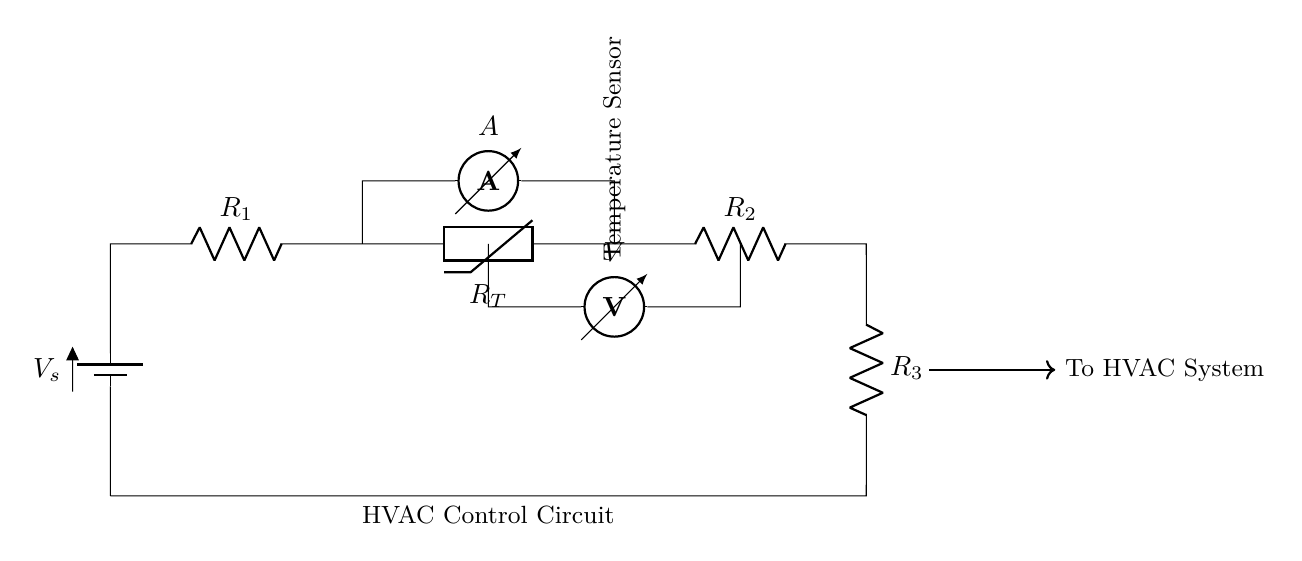What is the power source in this circuit? The power source is indicated by the battery symbol labeled V_s at the left side of the circuit, which provides the necessary voltage for the circuit to operate.
Answer: Battery What components are in series with the thermistor? The thermistor is positioned in a sequence with resistors R_1 and R_2, with R_1 preceding it and R_2 following it, hence they are in series with the thermistor.
Answer: R1, R2 What is the function of the ammeter in the circuit? The ammeter is used to measure the current flowing through the circuit, and it is placed in series with the thermistor to monitor the current specifically through this part of the circuit.
Answer: Measure current How does the temperature affect the circuit's output voltage? The thermistor's resistance decreases with increasing temperature, which affects the total resistance in the circuit and can consequently alter the output voltage across specific components like R_2.
Answer: Decreases voltage What type of sensor is used in this circuit? The temperature sensor integrated into the circuit is specifically a thermistor, which changes resistance based on temperature variations, allowing for temperature-sensitive control of the HVAC system.
Answer: Thermistor What is the primary purpose of this series circuit? The series circuit is mainly designed to regulate HVAC operations in secure document storage rooms by adjusting the system based on temperature readings from the thermistor.
Answer: HVAC regulation 